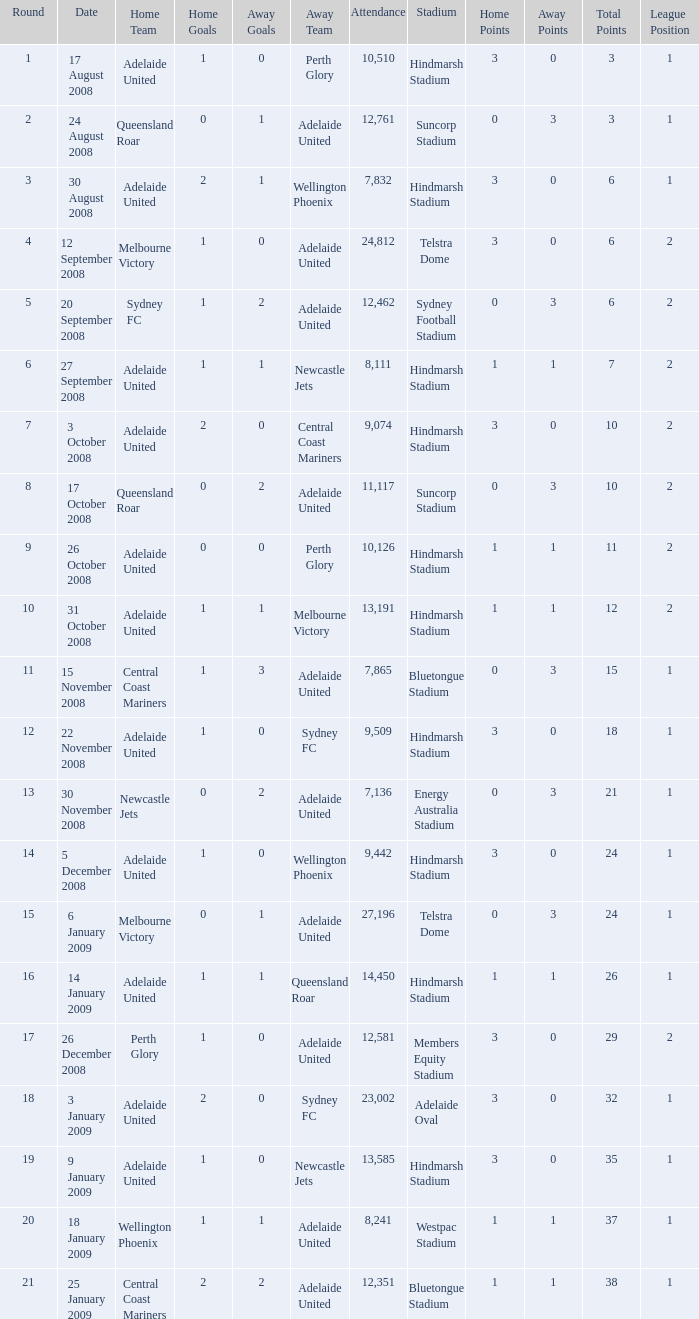Who was the away team when Queensland Roar was the home team in the round less than 3? Adelaide United. 